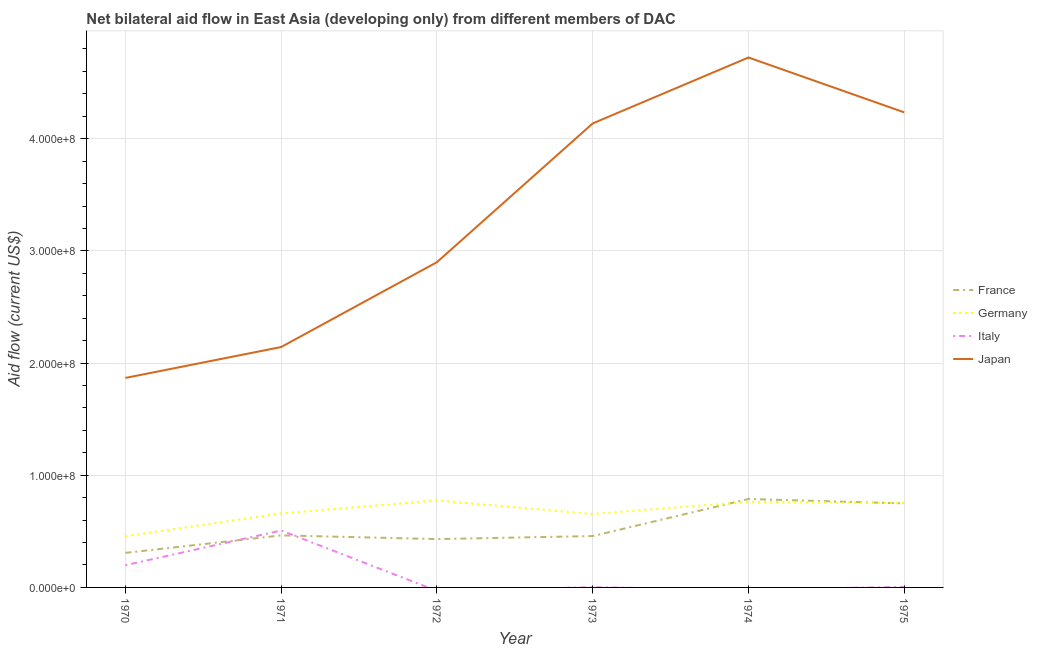Does the line corresponding to amount of aid given by italy intersect with the line corresponding to amount of aid given by japan?
Give a very brief answer. No. Is the number of lines equal to the number of legend labels?
Make the answer very short. No. What is the amount of aid given by italy in 1973?
Offer a very short reply. 1.60e+05. Across all years, what is the maximum amount of aid given by japan?
Your response must be concise. 4.72e+08. Across all years, what is the minimum amount of aid given by germany?
Provide a succinct answer. 4.56e+07. In which year was the amount of aid given by italy maximum?
Your answer should be very brief. 1971. What is the total amount of aid given by japan in the graph?
Your response must be concise. 2.00e+09. What is the difference between the amount of aid given by france in 1970 and that in 1975?
Provide a succinct answer. -4.41e+07. What is the difference between the amount of aid given by germany in 1974 and the amount of aid given by france in 1970?
Provide a short and direct response. 4.55e+07. What is the average amount of aid given by italy per year?
Provide a short and direct response. 1.19e+07. In the year 1975, what is the difference between the amount of aid given by germany and amount of aid given by japan?
Offer a very short reply. -3.48e+08. In how many years, is the amount of aid given by italy greater than 240000000 US$?
Your answer should be very brief. 0. What is the ratio of the amount of aid given by germany in 1971 to that in 1973?
Keep it short and to the point. 1.01. Is the difference between the amount of aid given by france in 1970 and 1973 greater than the difference between the amount of aid given by japan in 1970 and 1973?
Keep it short and to the point. Yes. What is the difference between the highest and the second highest amount of aid given by germany?
Ensure brevity in your answer.  1.25e+06. What is the difference between the highest and the lowest amount of aid given by italy?
Ensure brevity in your answer.  5.08e+07. Is it the case that in every year, the sum of the amount of aid given by france and amount of aid given by germany is greater than the amount of aid given by italy?
Provide a short and direct response. Yes. Does the amount of aid given by germany monotonically increase over the years?
Ensure brevity in your answer.  No. How many years are there in the graph?
Ensure brevity in your answer.  6. Are the values on the major ticks of Y-axis written in scientific E-notation?
Ensure brevity in your answer.  Yes. Does the graph contain any zero values?
Your answer should be very brief. Yes. Does the graph contain grids?
Keep it short and to the point. Yes. Where does the legend appear in the graph?
Ensure brevity in your answer.  Center right. How many legend labels are there?
Make the answer very short. 4. How are the legend labels stacked?
Offer a very short reply. Vertical. What is the title of the graph?
Ensure brevity in your answer.  Net bilateral aid flow in East Asia (developing only) from different members of DAC. Does "Fourth 20% of population" appear as one of the legend labels in the graph?
Make the answer very short. No. What is the Aid flow (current US$) of France in 1970?
Ensure brevity in your answer.  3.08e+07. What is the Aid flow (current US$) of Germany in 1970?
Ensure brevity in your answer.  4.56e+07. What is the Aid flow (current US$) in Italy in 1970?
Make the answer very short. 1.98e+07. What is the Aid flow (current US$) of Japan in 1970?
Provide a succinct answer. 1.87e+08. What is the Aid flow (current US$) of France in 1971?
Offer a very short reply. 4.64e+07. What is the Aid flow (current US$) of Germany in 1971?
Keep it short and to the point. 6.60e+07. What is the Aid flow (current US$) in Italy in 1971?
Ensure brevity in your answer.  5.08e+07. What is the Aid flow (current US$) in Japan in 1971?
Give a very brief answer. 2.14e+08. What is the Aid flow (current US$) of France in 1972?
Your answer should be very brief. 4.31e+07. What is the Aid flow (current US$) in Germany in 1972?
Provide a short and direct response. 7.75e+07. What is the Aid flow (current US$) of Italy in 1972?
Your answer should be very brief. 0. What is the Aid flow (current US$) of Japan in 1972?
Provide a short and direct response. 2.90e+08. What is the Aid flow (current US$) of France in 1973?
Offer a very short reply. 4.58e+07. What is the Aid flow (current US$) of Germany in 1973?
Your answer should be compact. 6.55e+07. What is the Aid flow (current US$) of Italy in 1973?
Offer a terse response. 1.60e+05. What is the Aid flow (current US$) in Japan in 1973?
Keep it short and to the point. 4.14e+08. What is the Aid flow (current US$) in France in 1974?
Your answer should be very brief. 7.88e+07. What is the Aid flow (current US$) in Germany in 1974?
Offer a very short reply. 7.63e+07. What is the Aid flow (current US$) in Italy in 1974?
Make the answer very short. 0. What is the Aid flow (current US$) of Japan in 1974?
Ensure brevity in your answer.  4.72e+08. What is the Aid flow (current US$) in France in 1975?
Your answer should be very brief. 7.49e+07. What is the Aid flow (current US$) of Germany in 1975?
Your response must be concise. 7.52e+07. What is the Aid flow (current US$) in Japan in 1975?
Offer a terse response. 4.24e+08. Across all years, what is the maximum Aid flow (current US$) of France?
Provide a short and direct response. 7.88e+07. Across all years, what is the maximum Aid flow (current US$) in Germany?
Offer a very short reply. 7.75e+07. Across all years, what is the maximum Aid flow (current US$) in Italy?
Your response must be concise. 5.08e+07. Across all years, what is the maximum Aid flow (current US$) in Japan?
Give a very brief answer. 4.72e+08. Across all years, what is the minimum Aid flow (current US$) in France?
Offer a very short reply. 3.08e+07. Across all years, what is the minimum Aid flow (current US$) of Germany?
Make the answer very short. 4.56e+07. Across all years, what is the minimum Aid flow (current US$) in Italy?
Offer a very short reply. 0. Across all years, what is the minimum Aid flow (current US$) of Japan?
Your answer should be very brief. 1.87e+08. What is the total Aid flow (current US$) of France in the graph?
Offer a very short reply. 3.20e+08. What is the total Aid flow (current US$) in Germany in the graph?
Give a very brief answer. 4.06e+08. What is the total Aid flow (current US$) in Italy in the graph?
Give a very brief answer. 7.12e+07. What is the total Aid flow (current US$) of Japan in the graph?
Offer a very short reply. 2.00e+09. What is the difference between the Aid flow (current US$) in France in 1970 and that in 1971?
Your response must be concise. -1.56e+07. What is the difference between the Aid flow (current US$) of Germany in 1970 and that in 1971?
Your answer should be compact. -2.04e+07. What is the difference between the Aid flow (current US$) of Italy in 1970 and that in 1971?
Offer a very short reply. -3.10e+07. What is the difference between the Aid flow (current US$) in Japan in 1970 and that in 1971?
Your answer should be compact. -2.76e+07. What is the difference between the Aid flow (current US$) in France in 1970 and that in 1972?
Provide a succinct answer. -1.23e+07. What is the difference between the Aid flow (current US$) of Germany in 1970 and that in 1972?
Make the answer very short. -3.19e+07. What is the difference between the Aid flow (current US$) in Japan in 1970 and that in 1972?
Provide a short and direct response. -1.03e+08. What is the difference between the Aid flow (current US$) in France in 1970 and that in 1973?
Ensure brevity in your answer.  -1.50e+07. What is the difference between the Aid flow (current US$) of Germany in 1970 and that in 1973?
Provide a short and direct response. -1.98e+07. What is the difference between the Aid flow (current US$) in Italy in 1970 and that in 1973?
Offer a very short reply. 1.96e+07. What is the difference between the Aid flow (current US$) in Japan in 1970 and that in 1973?
Your answer should be compact. -2.27e+08. What is the difference between the Aid flow (current US$) of France in 1970 and that in 1974?
Offer a terse response. -4.80e+07. What is the difference between the Aid flow (current US$) in Germany in 1970 and that in 1974?
Your answer should be very brief. -3.06e+07. What is the difference between the Aid flow (current US$) of Japan in 1970 and that in 1974?
Provide a succinct answer. -2.86e+08. What is the difference between the Aid flow (current US$) in France in 1970 and that in 1975?
Keep it short and to the point. -4.41e+07. What is the difference between the Aid flow (current US$) of Germany in 1970 and that in 1975?
Provide a short and direct response. -2.96e+07. What is the difference between the Aid flow (current US$) in Italy in 1970 and that in 1975?
Keep it short and to the point. 1.94e+07. What is the difference between the Aid flow (current US$) of Japan in 1970 and that in 1975?
Your answer should be compact. -2.37e+08. What is the difference between the Aid flow (current US$) of France in 1971 and that in 1972?
Give a very brief answer. 3.30e+06. What is the difference between the Aid flow (current US$) of Germany in 1971 and that in 1972?
Your response must be concise. -1.15e+07. What is the difference between the Aid flow (current US$) of Japan in 1971 and that in 1972?
Ensure brevity in your answer.  -7.56e+07. What is the difference between the Aid flow (current US$) in France in 1971 and that in 1973?
Make the answer very short. 6.10e+05. What is the difference between the Aid flow (current US$) in Germany in 1971 and that in 1973?
Your answer should be compact. 5.30e+05. What is the difference between the Aid flow (current US$) of Italy in 1971 and that in 1973?
Your answer should be very brief. 5.06e+07. What is the difference between the Aid flow (current US$) in Japan in 1971 and that in 1973?
Give a very brief answer. -1.99e+08. What is the difference between the Aid flow (current US$) in France in 1971 and that in 1974?
Keep it short and to the point. -3.24e+07. What is the difference between the Aid flow (current US$) in Germany in 1971 and that in 1974?
Make the answer very short. -1.03e+07. What is the difference between the Aid flow (current US$) of Japan in 1971 and that in 1974?
Offer a terse response. -2.58e+08. What is the difference between the Aid flow (current US$) of France in 1971 and that in 1975?
Your response must be concise. -2.85e+07. What is the difference between the Aid flow (current US$) in Germany in 1971 and that in 1975?
Make the answer very short. -9.24e+06. What is the difference between the Aid flow (current US$) of Italy in 1971 and that in 1975?
Offer a very short reply. 5.03e+07. What is the difference between the Aid flow (current US$) in Japan in 1971 and that in 1975?
Give a very brief answer. -2.09e+08. What is the difference between the Aid flow (current US$) of France in 1972 and that in 1973?
Give a very brief answer. -2.69e+06. What is the difference between the Aid flow (current US$) in Germany in 1972 and that in 1973?
Offer a very short reply. 1.20e+07. What is the difference between the Aid flow (current US$) in Japan in 1972 and that in 1973?
Your answer should be very brief. -1.24e+08. What is the difference between the Aid flow (current US$) of France in 1972 and that in 1974?
Make the answer very short. -3.57e+07. What is the difference between the Aid flow (current US$) in Germany in 1972 and that in 1974?
Offer a terse response. 1.25e+06. What is the difference between the Aid flow (current US$) of Japan in 1972 and that in 1974?
Provide a succinct answer. -1.82e+08. What is the difference between the Aid flow (current US$) of France in 1972 and that in 1975?
Your answer should be compact. -3.18e+07. What is the difference between the Aid flow (current US$) in Germany in 1972 and that in 1975?
Your answer should be very brief. 2.28e+06. What is the difference between the Aid flow (current US$) in Japan in 1972 and that in 1975?
Make the answer very short. -1.34e+08. What is the difference between the Aid flow (current US$) of France in 1973 and that in 1974?
Your response must be concise. -3.30e+07. What is the difference between the Aid flow (current US$) in Germany in 1973 and that in 1974?
Keep it short and to the point. -1.08e+07. What is the difference between the Aid flow (current US$) in Japan in 1973 and that in 1974?
Provide a short and direct response. -5.88e+07. What is the difference between the Aid flow (current US$) in France in 1973 and that in 1975?
Keep it short and to the point. -2.91e+07. What is the difference between the Aid flow (current US$) of Germany in 1973 and that in 1975?
Make the answer very short. -9.77e+06. What is the difference between the Aid flow (current US$) in Italy in 1973 and that in 1975?
Make the answer very short. -2.80e+05. What is the difference between the Aid flow (current US$) in Japan in 1973 and that in 1975?
Give a very brief answer. -9.88e+06. What is the difference between the Aid flow (current US$) of France in 1974 and that in 1975?
Keep it short and to the point. 3.97e+06. What is the difference between the Aid flow (current US$) of Germany in 1974 and that in 1975?
Keep it short and to the point. 1.03e+06. What is the difference between the Aid flow (current US$) in Japan in 1974 and that in 1975?
Give a very brief answer. 4.89e+07. What is the difference between the Aid flow (current US$) of France in 1970 and the Aid flow (current US$) of Germany in 1971?
Keep it short and to the point. -3.52e+07. What is the difference between the Aid flow (current US$) of France in 1970 and the Aid flow (current US$) of Italy in 1971?
Your answer should be very brief. -2.00e+07. What is the difference between the Aid flow (current US$) in France in 1970 and the Aid flow (current US$) in Japan in 1971?
Your answer should be very brief. -1.84e+08. What is the difference between the Aid flow (current US$) of Germany in 1970 and the Aid flow (current US$) of Italy in 1971?
Offer a very short reply. -5.13e+06. What is the difference between the Aid flow (current US$) in Germany in 1970 and the Aid flow (current US$) in Japan in 1971?
Provide a succinct answer. -1.69e+08. What is the difference between the Aid flow (current US$) in Italy in 1970 and the Aid flow (current US$) in Japan in 1971?
Provide a succinct answer. -1.94e+08. What is the difference between the Aid flow (current US$) in France in 1970 and the Aid flow (current US$) in Germany in 1972?
Give a very brief answer. -4.67e+07. What is the difference between the Aid flow (current US$) of France in 1970 and the Aid flow (current US$) of Japan in 1972?
Ensure brevity in your answer.  -2.59e+08. What is the difference between the Aid flow (current US$) in Germany in 1970 and the Aid flow (current US$) in Japan in 1972?
Provide a short and direct response. -2.44e+08. What is the difference between the Aid flow (current US$) in Italy in 1970 and the Aid flow (current US$) in Japan in 1972?
Ensure brevity in your answer.  -2.70e+08. What is the difference between the Aid flow (current US$) in France in 1970 and the Aid flow (current US$) in Germany in 1973?
Your answer should be very brief. -3.47e+07. What is the difference between the Aid flow (current US$) in France in 1970 and the Aid flow (current US$) in Italy in 1973?
Give a very brief answer. 3.06e+07. What is the difference between the Aid flow (current US$) of France in 1970 and the Aid flow (current US$) of Japan in 1973?
Your answer should be very brief. -3.83e+08. What is the difference between the Aid flow (current US$) in Germany in 1970 and the Aid flow (current US$) in Italy in 1973?
Your response must be concise. 4.55e+07. What is the difference between the Aid flow (current US$) of Germany in 1970 and the Aid flow (current US$) of Japan in 1973?
Your response must be concise. -3.68e+08. What is the difference between the Aid flow (current US$) of Italy in 1970 and the Aid flow (current US$) of Japan in 1973?
Provide a succinct answer. -3.94e+08. What is the difference between the Aid flow (current US$) of France in 1970 and the Aid flow (current US$) of Germany in 1974?
Offer a very short reply. -4.55e+07. What is the difference between the Aid flow (current US$) of France in 1970 and the Aid flow (current US$) of Japan in 1974?
Give a very brief answer. -4.42e+08. What is the difference between the Aid flow (current US$) of Germany in 1970 and the Aid flow (current US$) of Japan in 1974?
Your answer should be compact. -4.27e+08. What is the difference between the Aid flow (current US$) of Italy in 1970 and the Aid flow (current US$) of Japan in 1974?
Offer a very short reply. -4.53e+08. What is the difference between the Aid flow (current US$) of France in 1970 and the Aid flow (current US$) of Germany in 1975?
Keep it short and to the point. -4.44e+07. What is the difference between the Aid flow (current US$) of France in 1970 and the Aid flow (current US$) of Italy in 1975?
Offer a very short reply. 3.04e+07. What is the difference between the Aid flow (current US$) of France in 1970 and the Aid flow (current US$) of Japan in 1975?
Your answer should be compact. -3.93e+08. What is the difference between the Aid flow (current US$) of Germany in 1970 and the Aid flow (current US$) of Italy in 1975?
Your response must be concise. 4.52e+07. What is the difference between the Aid flow (current US$) in Germany in 1970 and the Aid flow (current US$) in Japan in 1975?
Your response must be concise. -3.78e+08. What is the difference between the Aid flow (current US$) in Italy in 1970 and the Aid flow (current US$) in Japan in 1975?
Your answer should be compact. -4.04e+08. What is the difference between the Aid flow (current US$) of France in 1971 and the Aid flow (current US$) of Germany in 1972?
Your answer should be compact. -3.11e+07. What is the difference between the Aid flow (current US$) in France in 1971 and the Aid flow (current US$) in Japan in 1972?
Make the answer very short. -2.44e+08. What is the difference between the Aid flow (current US$) in Germany in 1971 and the Aid flow (current US$) in Japan in 1972?
Ensure brevity in your answer.  -2.24e+08. What is the difference between the Aid flow (current US$) of Italy in 1971 and the Aid flow (current US$) of Japan in 1972?
Keep it short and to the point. -2.39e+08. What is the difference between the Aid flow (current US$) in France in 1971 and the Aid flow (current US$) in Germany in 1973?
Your answer should be very brief. -1.91e+07. What is the difference between the Aid flow (current US$) of France in 1971 and the Aid flow (current US$) of Italy in 1973?
Make the answer very short. 4.62e+07. What is the difference between the Aid flow (current US$) of France in 1971 and the Aid flow (current US$) of Japan in 1973?
Your answer should be compact. -3.67e+08. What is the difference between the Aid flow (current US$) of Germany in 1971 and the Aid flow (current US$) of Italy in 1973?
Offer a very short reply. 6.58e+07. What is the difference between the Aid flow (current US$) in Germany in 1971 and the Aid flow (current US$) in Japan in 1973?
Your answer should be very brief. -3.48e+08. What is the difference between the Aid flow (current US$) of Italy in 1971 and the Aid flow (current US$) of Japan in 1973?
Your response must be concise. -3.63e+08. What is the difference between the Aid flow (current US$) in France in 1971 and the Aid flow (current US$) in Germany in 1974?
Offer a terse response. -2.99e+07. What is the difference between the Aid flow (current US$) in France in 1971 and the Aid flow (current US$) in Japan in 1974?
Your response must be concise. -4.26e+08. What is the difference between the Aid flow (current US$) of Germany in 1971 and the Aid flow (current US$) of Japan in 1974?
Ensure brevity in your answer.  -4.06e+08. What is the difference between the Aid flow (current US$) in Italy in 1971 and the Aid flow (current US$) in Japan in 1974?
Your answer should be compact. -4.22e+08. What is the difference between the Aid flow (current US$) of France in 1971 and the Aid flow (current US$) of Germany in 1975?
Give a very brief answer. -2.88e+07. What is the difference between the Aid flow (current US$) of France in 1971 and the Aid flow (current US$) of Italy in 1975?
Your answer should be very brief. 4.60e+07. What is the difference between the Aid flow (current US$) of France in 1971 and the Aid flow (current US$) of Japan in 1975?
Provide a succinct answer. -3.77e+08. What is the difference between the Aid flow (current US$) in Germany in 1971 and the Aid flow (current US$) in Italy in 1975?
Give a very brief answer. 6.56e+07. What is the difference between the Aid flow (current US$) of Germany in 1971 and the Aid flow (current US$) of Japan in 1975?
Offer a very short reply. -3.58e+08. What is the difference between the Aid flow (current US$) of Italy in 1971 and the Aid flow (current US$) of Japan in 1975?
Your answer should be compact. -3.73e+08. What is the difference between the Aid flow (current US$) in France in 1972 and the Aid flow (current US$) in Germany in 1973?
Provide a succinct answer. -2.24e+07. What is the difference between the Aid flow (current US$) in France in 1972 and the Aid flow (current US$) in Italy in 1973?
Your response must be concise. 4.29e+07. What is the difference between the Aid flow (current US$) of France in 1972 and the Aid flow (current US$) of Japan in 1973?
Offer a very short reply. -3.71e+08. What is the difference between the Aid flow (current US$) in Germany in 1972 and the Aid flow (current US$) in Italy in 1973?
Ensure brevity in your answer.  7.74e+07. What is the difference between the Aid flow (current US$) of Germany in 1972 and the Aid flow (current US$) of Japan in 1973?
Your answer should be compact. -3.36e+08. What is the difference between the Aid flow (current US$) of France in 1972 and the Aid flow (current US$) of Germany in 1974?
Give a very brief answer. -3.32e+07. What is the difference between the Aid flow (current US$) of France in 1972 and the Aid flow (current US$) of Japan in 1974?
Your response must be concise. -4.29e+08. What is the difference between the Aid flow (current US$) in Germany in 1972 and the Aid flow (current US$) in Japan in 1974?
Provide a succinct answer. -3.95e+08. What is the difference between the Aid flow (current US$) in France in 1972 and the Aid flow (current US$) in Germany in 1975?
Provide a short and direct response. -3.21e+07. What is the difference between the Aid flow (current US$) in France in 1972 and the Aid flow (current US$) in Italy in 1975?
Provide a succinct answer. 4.27e+07. What is the difference between the Aid flow (current US$) in France in 1972 and the Aid flow (current US$) in Japan in 1975?
Provide a succinct answer. -3.80e+08. What is the difference between the Aid flow (current US$) in Germany in 1972 and the Aid flow (current US$) in Italy in 1975?
Offer a terse response. 7.71e+07. What is the difference between the Aid flow (current US$) in Germany in 1972 and the Aid flow (current US$) in Japan in 1975?
Your response must be concise. -3.46e+08. What is the difference between the Aid flow (current US$) in France in 1973 and the Aid flow (current US$) in Germany in 1974?
Your answer should be compact. -3.05e+07. What is the difference between the Aid flow (current US$) in France in 1973 and the Aid flow (current US$) in Japan in 1974?
Offer a terse response. -4.27e+08. What is the difference between the Aid flow (current US$) in Germany in 1973 and the Aid flow (current US$) in Japan in 1974?
Offer a very short reply. -4.07e+08. What is the difference between the Aid flow (current US$) of Italy in 1973 and the Aid flow (current US$) of Japan in 1974?
Give a very brief answer. -4.72e+08. What is the difference between the Aid flow (current US$) of France in 1973 and the Aid flow (current US$) of Germany in 1975?
Make the answer very short. -2.94e+07. What is the difference between the Aid flow (current US$) of France in 1973 and the Aid flow (current US$) of Italy in 1975?
Your answer should be very brief. 4.54e+07. What is the difference between the Aid flow (current US$) in France in 1973 and the Aid flow (current US$) in Japan in 1975?
Your answer should be very brief. -3.78e+08. What is the difference between the Aid flow (current US$) in Germany in 1973 and the Aid flow (current US$) in Italy in 1975?
Your answer should be very brief. 6.50e+07. What is the difference between the Aid flow (current US$) in Germany in 1973 and the Aid flow (current US$) in Japan in 1975?
Offer a very short reply. -3.58e+08. What is the difference between the Aid flow (current US$) of Italy in 1973 and the Aid flow (current US$) of Japan in 1975?
Give a very brief answer. -4.23e+08. What is the difference between the Aid flow (current US$) in France in 1974 and the Aid flow (current US$) in Germany in 1975?
Make the answer very short. 3.61e+06. What is the difference between the Aid flow (current US$) of France in 1974 and the Aid flow (current US$) of Italy in 1975?
Provide a succinct answer. 7.84e+07. What is the difference between the Aid flow (current US$) in France in 1974 and the Aid flow (current US$) in Japan in 1975?
Provide a succinct answer. -3.45e+08. What is the difference between the Aid flow (current US$) of Germany in 1974 and the Aid flow (current US$) of Italy in 1975?
Make the answer very short. 7.58e+07. What is the difference between the Aid flow (current US$) in Germany in 1974 and the Aid flow (current US$) in Japan in 1975?
Provide a succinct answer. -3.47e+08. What is the average Aid flow (current US$) in France per year?
Ensure brevity in your answer.  5.33e+07. What is the average Aid flow (current US$) in Germany per year?
Offer a very short reply. 6.77e+07. What is the average Aid flow (current US$) of Italy per year?
Offer a terse response. 1.19e+07. What is the average Aid flow (current US$) in Japan per year?
Your response must be concise. 3.33e+08. In the year 1970, what is the difference between the Aid flow (current US$) in France and Aid flow (current US$) in Germany?
Offer a terse response. -1.48e+07. In the year 1970, what is the difference between the Aid flow (current US$) of France and Aid flow (current US$) of Italy?
Your answer should be very brief. 1.10e+07. In the year 1970, what is the difference between the Aid flow (current US$) of France and Aid flow (current US$) of Japan?
Ensure brevity in your answer.  -1.56e+08. In the year 1970, what is the difference between the Aid flow (current US$) of Germany and Aid flow (current US$) of Italy?
Give a very brief answer. 2.58e+07. In the year 1970, what is the difference between the Aid flow (current US$) of Germany and Aid flow (current US$) of Japan?
Provide a short and direct response. -1.41e+08. In the year 1970, what is the difference between the Aid flow (current US$) in Italy and Aid flow (current US$) in Japan?
Provide a short and direct response. -1.67e+08. In the year 1971, what is the difference between the Aid flow (current US$) in France and Aid flow (current US$) in Germany?
Ensure brevity in your answer.  -1.96e+07. In the year 1971, what is the difference between the Aid flow (current US$) in France and Aid flow (current US$) in Italy?
Your answer should be very brief. -4.36e+06. In the year 1971, what is the difference between the Aid flow (current US$) in France and Aid flow (current US$) in Japan?
Make the answer very short. -1.68e+08. In the year 1971, what is the difference between the Aid flow (current US$) in Germany and Aid flow (current US$) in Italy?
Provide a short and direct response. 1.52e+07. In the year 1971, what is the difference between the Aid flow (current US$) of Germany and Aid flow (current US$) of Japan?
Keep it short and to the point. -1.48e+08. In the year 1971, what is the difference between the Aid flow (current US$) in Italy and Aid flow (current US$) in Japan?
Offer a terse response. -1.64e+08. In the year 1972, what is the difference between the Aid flow (current US$) of France and Aid flow (current US$) of Germany?
Ensure brevity in your answer.  -3.44e+07. In the year 1972, what is the difference between the Aid flow (current US$) in France and Aid flow (current US$) in Japan?
Your answer should be very brief. -2.47e+08. In the year 1972, what is the difference between the Aid flow (current US$) in Germany and Aid flow (current US$) in Japan?
Give a very brief answer. -2.12e+08. In the year 1973, what is the difference between the Aid flow (current US$) of France and Aid flow (current US$) of Germany?
Offer a terse response. -1.97e+07. In the year 1973, what is the difference between the Aid flow (current US$) of France and Aid flow (current US$) of Italy?
Give a very brief answer. 4.56e+07. In the year 1973, what is the difference between the Aid flow (current US$) of France and Aid flow (current US$) of Japan?
Ensure brevity in your answer.  -3.68e+08. In the year 1973, what is the difference between the Aid flow (current US$) of Germany and Aid flow (current US$) of Italy?
Provide a succinct answer. 6.53e+07. In the year 1973, what is the difference between the Aid flow (current US$) of Germany and Aid flow (current US$) of Japan?
Give a very brief answer. -3.48e+08. In the year 1973, what is the difference between the Aid flow (current US$) of Italy and Aid flow (current US$) of Japan?
Your answer should be compact. -4.13e+08. In the year 1974, what is the difference between the Aid flow (current US$) of France and Aid flow (current US$) of Germany?
Your answer should be very brief. 2.58e+06. In the year 1974, what is the difference between the Aid flow (current US$) of France and Aid flow (current US$) of Japan?
Your answer should be very brief. -3.94e+08. In the year 1974, what is the difference between the Aid flow (current US$) of Germany and Aid flow (current US$) of Japan?
Your answer should be very brief. -3.96e+08. In the year 1975, what is the difference between the Aid flow (current US$) of France and Aid flow (current US$) of Germany?
Your answer should be very brief. -3.60e+05. In the year 1975, what is the difference between the Aid flow (current US$) in France and Aid flow (current US$) in Italy?
Your response must be concise. 7.44e+07. In the year 1975, what is the difference between the Aid flow (current US$) of France and Aid flow (current US$) of Japan?
Provide a succinct answer. -3.49e+08. In the year 1975, what is the difference between the Aid flow (current US$) of Germany and Aid flow (current US$) of Italy?
Your answer should be compact. 7.48e+07. In the year 1975, what is the difference between the Aid flow (current US$) in Germany and Aid flow (current US$) in Japan?
Offer a very short reply. -3.48e+08. In the year 1975, what is the difference between the Aid flow (current US$) of Italy and Aid flow (current US$) of Japan?
Give a very brief answer. -4.23e+08. What is the ratio of the Aid flow (current US$) of France in 1970 to that in 1971?
Your response must be concise. 0.66. What is the ratio of the Aid flow (current US$) of Germany in 1970 to that in 1971?
Provide a short and direct response. 0.69. What is the ratio of the Aid flow (current US$) in Italy in 1970 to that in 1971?
Ensure brevity in your answer.  0.39. What is the ratio of the Aid flow (current US$) of Japan in 1970 to that in 1971?
Give a very brief answer. 0.87. What is the ratio of the Aid flow (current US$) in France in 1970 to that in 1972?
Provide a short and direct response. 0.71. What is the ratio of the Aid flow (current US$) of Germany in 1970 to that in 1972?
Your answer should be compact. 0.59. What is the ratio of the Aid flow (current US$) of Japan in 1970 to that in 1972?
Ensure brevity in your answer.  0.64. What is the ratio of the Aid flow (current US$) of France in 1970 to that in 1973?
Ensure brevity in your answer.  0.67. What is the ratio of the Aid flow (current US$) in Germany in 1970 to that in 1973?
Provide a short and direct response. 0.7. What is the ratio of the Aid flow (current US$) in Italy in 1970 to that in 1973?
Make the answer very short. 123.81. What is the ratio of the Aid flow (current US$) in Japan in 1970 to that in 1973?
Offer a terse response. 0.45. What is the ratio of the Aid flow (current US$) in France in 1970 to that in 1974?
Your response must be concise. 0.39. What is the ratio of the Aid flow (current US$) of Germany in 1970 to that in 1974?
Make the answer very short. 0.6. What is the ratio of the Aid flow (current US$) in Japan in 1970 to that in 1974?
Your answer should be compact. 0.4. What is the ratio of the Aid flow (current US$) of France in 1970 to that in 1975?
Give a very brief answer. 0.41. What is the ratio of the Aid flow (current US$) in Germany in 1970 to that in 1975?
Give a very brief answer. 0.61. What is the ratio of the Aid flow (current US$) in Italy in 1970 to that in 1975?
Your answer should be very brief. 45.02. What is the ratio of the Aid flow (current US$) of Japan in 1970 to that in 1975?
Give a very brief answer. 0.44. What is the ratio of the Aid flow (current US$) in France in 1971 to that in 1972?
Your answer should be very brief. 1.08. What is the ratio of the Aid flow (current US$) in Germany in 1971 to that in 1972?
Keep it short and to the point. 0.85. What is the ratio of the Aid flow (current US$) in Japan in 1971 to that in 1972?
Your answer should be very brief. 0.74. What is the ratio of the Aid flow (current US$) of France in 1971 to that in 1973?
Offer a terse response. 1.01. What is the ratio of the Aid flow (current US$) of Germany in 1971 to that in 1973?
Offer a terse response. 1.01. What is the ratio of the Aid flow (current US$) in Italy in 1971 to that in 1973?
Ensure brevity in your answer.  317.25. What is the ratio of the Aid flow (current US$) in Japan in 1971 to that in 1973?
Your answer should be compact. 0.52. What is the ratio of the Aid flow (current US$) of France in 1971 to that in 1974?
Make the answer very short. 0.59. What is the ratio of the Aid flow (current US$) of Germany in 1971 to that in 1974?
Provide a succinct answer. 0.87. What is the ratio of the Aid flow (current US$) in Japan in 1971 to that in 1974?
Your response must be concise. 0.45. What is the ratio of the Aid flow (current US$) in France in 1971 to that in 1975?
Offer a terse response. 0.62. What is the ratio of the Aid flow (current US$) of Germany in 1971 to that in 1975?
Provide a succinct answer. 0.88. What is the ratio of the Aid flow (current US$) in Italy in 1971 to that in 1975?
Ensure brevity in your answer.  115.36. What is the ratio of the Aid flow (current US$) in Japan in 1971 to that in 1975?
Provide a succinct answer. 0.51. What is the ratio of the Aid flow (current US$) of France in 1972 to that in 1973?
Keep it short and to the point. 0.94. What is the ratio of the Aid flow (current US$) of Germany in 1972 to that in 1973?
Offer a terse response. 1.18. What is the ratio of the Aid flow (current US$) of Japan in 1972 to that in 1973?
Ensure brevity in your answer.  0.7. What is the ratio of the Aid flow (current US$) of France in 1972 to that in 1974?
Your response must be concise. 0.55. What is the ratio of the Aid flow (current US$) of Germany in 1972 to that in 1974?
Provide a short and direct response. 1.02. What is the ratio of the Aid flow (current US$) in Japan in 1972 to that in 1974?
Offer a very short reply. 0.61. What is the ratio of the Aid flow (current US$) in France in 1972 to that in 1975?
Ensure brevity in your answer.  0.58. What is the ratio of the Aid flow (current US$) of Germany in 1972 to that in 1975?
Provide a short and direct response. 1.03. What is the ratio of the Aid flow (current US$) in Japan in 1972 to that in 1975?
Provide a short and direct response. 0.68. What is the ratio of the Aid flow (current US$) in France in 1973 to that in 1974?
Provide a succinct answer. 0.58. What is the ratio of the Aid flow (current US$) of Germany in 1973 to that in 1974?
Your answer should be very brief. 0.86. What is the ratio of the Aid flow (current US$) of Japan in 1973 to that in 1974?
Provide a succinct answer. 0.88. What is the ratio of the Aid flow (current US$) in France in 1973 to that in 1975?
Keep it short and to the point. 0.61. What is the ratio of the Aid flow (current US$) in Germany in 1973 to that in 1975?
Keep it short and to the point. 0.87. What is the ratio of the Aid flow (current US$) in Italy in 1973 to that in 1975?
Make the answer very short. 0.36. What is the ratio of the Aid flow (current US$) of Japan in 1973 to that in 1975?
Provide a succinct answer. 0.98. What is the ratio of the Aid flow (current US$) of France in 1974 to that in 1975?
Provide a succinct answer. 1.05. What is the ratio of the Aid flow (current US$) of Germany in 1974 to that in 1975?
Offer a very short reply. 1.01. What is the ratio of the Aid flow (current US$) of Japan in 1974 to that in 1975?
Keep it short and to the point. 1.12. What is the difference between the highest and the second highest Aid flow (current US$) in France?
Your answer should be very brief. 3.97e+06. What is the difference between the highest and the second highest Aid flow (current US$) in Germany?
Offer a very short reply. 1.25e+06. What is the difference between the highest and the second highest Aid flow (current US$) in Italy?
Make the answer very short. 3.10e+07. What is the difference between the highest and the second highest Aid flow (current US$) in Japan?
Ensure brevity in your answer.  4.89e+07. What is the difference between the highest and the lowest Aid flow (current US$) in France?
Your answer should be very brief. 4.80e+07. What is the difference between the highest and the lowest Aid flow (current US$) in Germany?
Your response must be concise. 3.19e+07. What is the difference between the highest and the lowest Aid flow (current US$) of Italy?
Your answer should be compact. 5.08e+07. What is the difference between the highest and the lowest Aid flow (current US$) in Japan?
Your response must be concise. 2.86e+08. 